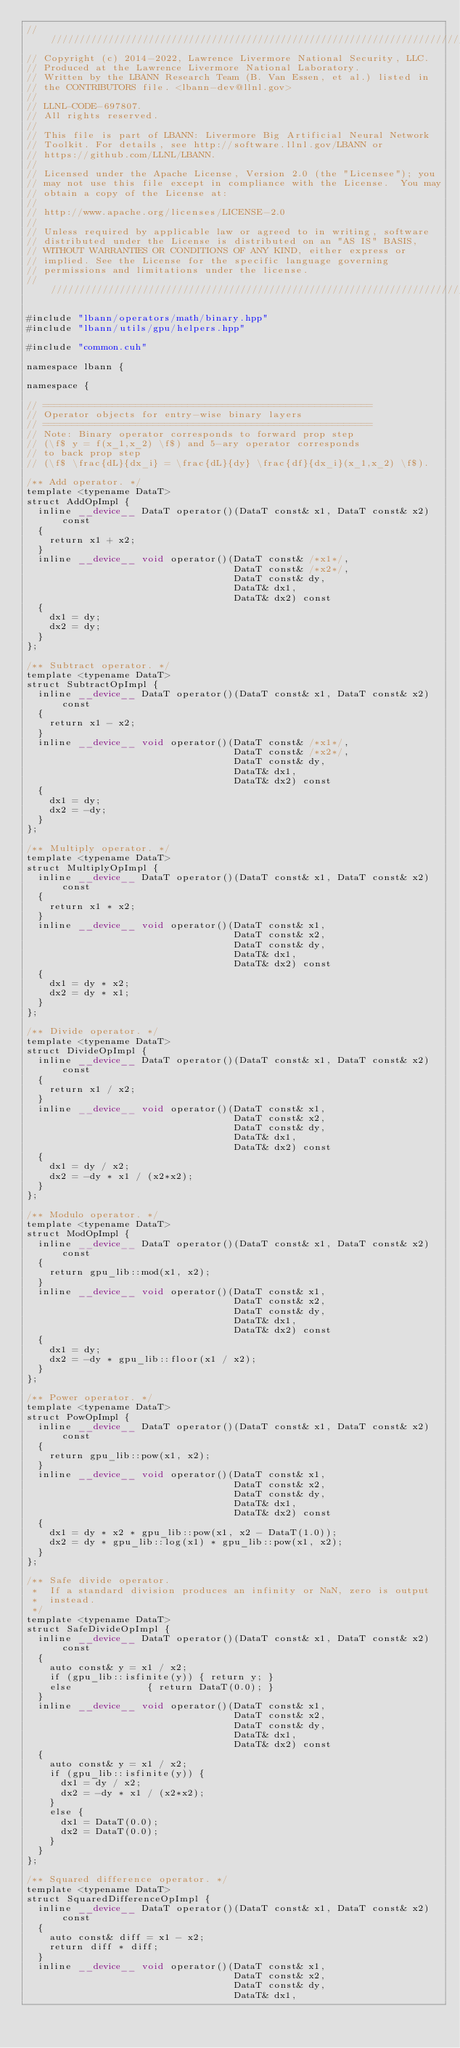<code> <loc_0><loc_0><loc_500><loc_500><_Cuda_>////////////////////////////////////////////////////////////////////////////////
// Copyright (c) 2014-2022, Lawrence Livermore National Security, LLC.
// Produced at the Lawrence Livermore National Laboratory.
// Written by the LBANN Research Team (B. Van Essen, et al.) listed in
// the CONTRIBUTORS file. <lbann-dev@llnl.gov>
//
// LLNL-CODE-697807.
// All rights reserved.
//
// This file is part of LBANN: Livermore Big Artificial Neural Network
// Toolkit. For details, see http://software.llnl.gov/LBANN or
// https://github.com/LLNL/LBANN.
//
// Licensed under the Apache License, Version 2.0 (the "Licensee"); you
// may not use this file except in compliance with the License.  You may
// obtain a copy of the License at:
//
// http://www.apache.org/licenses/LICENSE-2.0
//
// Unless required by applicable law or agreed to in writing, software
// distributed under the License is distributed on an "AS IS" BASIS,
// WITHOUT WARRANTIES OR CONDITIONS OF ANY KIND, either express or
// implied. See the License for the specific language governing
// permissions and limitations under the license.
////////////////////////////////////////////////////////////////////////////////

#include "lbann/operators/math/binary.hpp"
#include "lbann/utils/gpu/helpers.hpp"

#include "common.cuh"

namespace lbann {

namespace {

// =========================================================
// Operator objects for entry-wise binary layers
// =========================================================
// Note: Binary operator corresponds to forward prop step
// (\f$ y = f(x_1,x_2) \f$) and 5-ary operator corresponds
// to back prop step
// (\f$ \frac{dL}{dx_i} = \frac{dL}{dy} \frac{df}{dx_i}(x_1,x_2) \f$).

/** Add operator. */
template <typename DataT>
struct AddOpImpl {
  inline __device__ DataT operator()(DataT const& x1, DataT const& x2) const
  {
    return x1 + x2;
  }
  inline __device__ void operator()(DataT const& /*x1*/,
                                    DataT const& /*x2*/,
                                    DataT const& dy,
                                    DataT& dx1,
                                    DataT& dx2) const
  {
    dx1 = dy;
    dx2 = dy;
  }
};

/** Subtract operator. */
template <typename DataT>
struct SubtractOpImpl {
  inline __device__ DataT operator()(DataT const& x1, DataT const& x2) const
  {
    return x1 - x2;
  }
  inline __device__ void operator()(DataT const& /*x1*/,
                                    DataT const& /*x2*/,
                                    DataT const& dy,
                                    DataT& dx1,
                                    DataT& dx2) const
  {
    dx1 = dy;
    dx2 = -dy;
  }
};

/** Multiply operator. */
template <typename DataT>
struct MultiplyOpImpl {
  inline __device__ DataT operator()(DataT const& x1, DataT const& x2) const
  {
    return x1 * x2;
  }
  inline __device__ void operator()(DataT const& x1,
                                    DataT const& x2,
                                    DataT const& dy,
                                    DataT& dx1,
                                    DataT& dx2) const
  {
    dx1 = dy * x2;
    dx2 = dy * x1;
  }
};

/** Divide operator. */
template <typename DataT>
struct DivideOpImpl {
  inline __device__ DataT operator()(DataT const& x1, DataT const& x2) const
  {
    return x1 / x2;
  }
  inline __device__ void operator()(DataT const& x1,
                                    DataT const& x2,
                                    DataT const& dy,
                                    DataT& dx1,
                                    DataT& dx2) const
  {
    dx1 = dy / x2;
    dx2 = -dy * x1 / (x2*x2);
  }
};

/** Modulo operator. */
template <typename DataT>
struct ModOpImpl {
  inline __device__ DataT operator()(DataT const& x1, DataT const& x2) const
  {
    return gpu_lib::mod(x1, x2);
  }
  inline __device__ void operator()(DataT const& x1,
                                    DataT const& x2,
                                    DataT const& dy,
                                    DataT& dx1,
                                    DataT& dx2) const
  {
    dx1 = dy;
    dx2 = -dy * gpu_lib::floor(x1 / x2);
  }
};

/** Power operator. */
template <typename DataT>
struct PowOpImpl {
  inline __device__ DataT operator()(DataT const& x1, DataT const& x2) const
  {
    return gpu_lib::pow(x1, x2);
  }
  inline __device__ void operator()(DataT const& x1,
                                    DataT const& x2,
                                    DataT const& dy,
                                    DataT& dx1,
                                    DataT& dx2) const
  {
    dx1 = dy * x2 * gpu_lib::pow(x1, x2 - DataT(1.0));
    dx2 = dy * gpu_lib::log(x1) * gpu_lib::pow(x1, x2);
  }
};

/** Safe divide operator.
 *  If a standard division produces an infinity or NaN, zero is output
 *  instead.
 */
template <typename DataT>
struct SafeDivideOpImpl {
  inline __device__ DataT operator()(DataT const& x1, DataT const& x2) const
  {
    auto const& y = x1 / x2;
    if (gpu_lib::isfinite(y)) { return y; }
    else             { return DataT(0.0); }
  }
  inline __device__ void operator()(DataT const& x1,
                                    DataT const& x2,
                                    DataT const& dy,
                                    DataT& dx1,
                                    DataT& dx2) const
  {
    auto const& y = x1 / x2;
    if (gpu_lib::isfinite(y)) {
      dx1 = dy / x2;
      dx2 = -dy * x1 / (x2*x2);
    }
    else {
      dx1 = DataT(0.0);
      dx2 = DataT(0.0);
    }
  }
};

/** Squared difference operator. */
template <typename DataT>
struct SquaredDifferenceOpImpl {
  inline __device__ DataT operator()(DataT const& x1, DataT const& x2) const
  {
    auto const& diff = x1 - x2;
    return diff * diff;
  }
  inline __device__ void operator()(DataT const& x1,
                                    DataT const& x2,
                                    DataT const& dy,
                                    DataT& dx1,</code> 